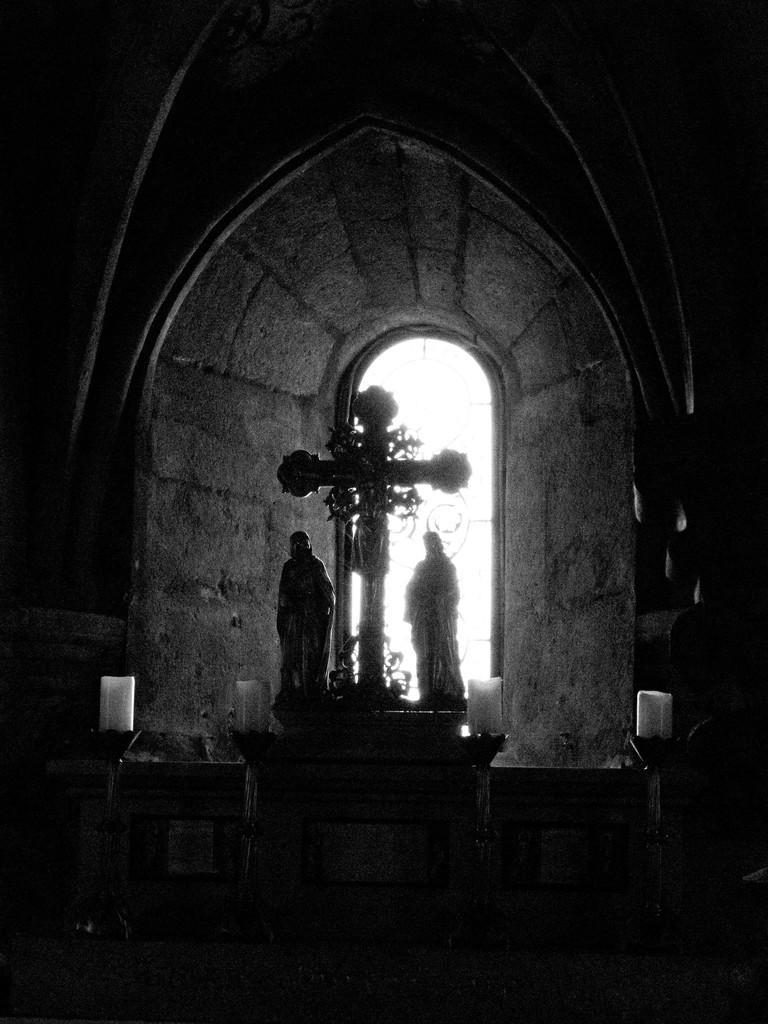Please provide a concise description of this image. In the middle of this image there is a crucifix and two sculptures of persons. In the background there is a window to the wall. At the bottom there is a table. The background is dark. 